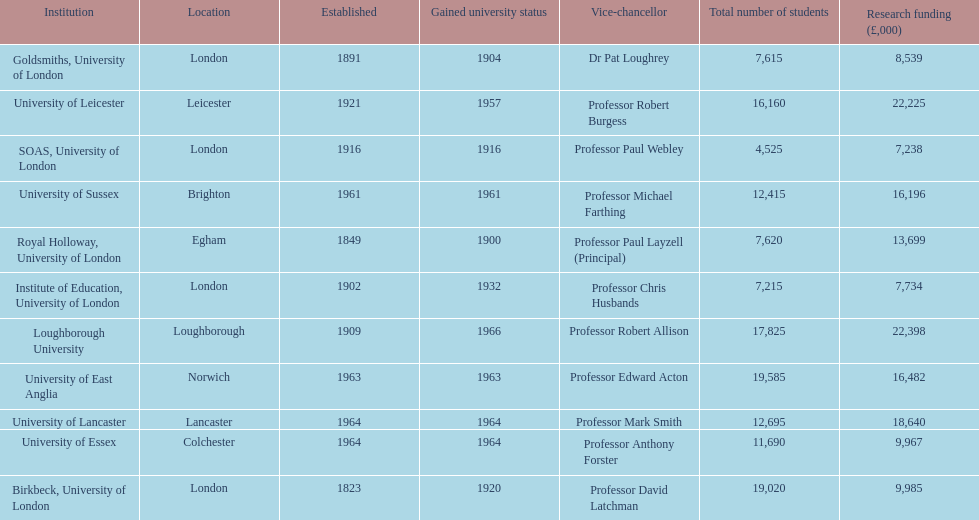Which institution has the most research funding? Loughborough University. 